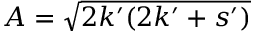<formula> <loc_0><loc_0><loc_500><loc_500>A = \sqrt { 2 k ^ { \prime } ( 2 k ^ { \prime } + s ^ { \prime } ) }</formula> 